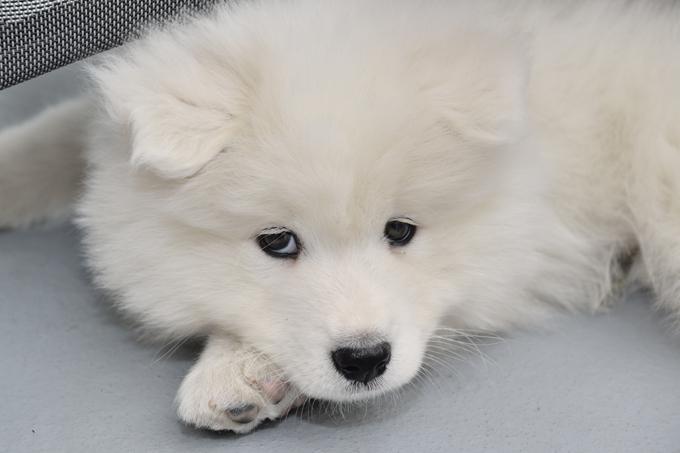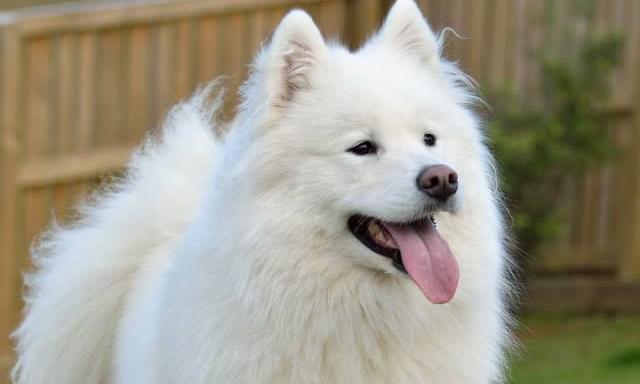The first image is the image on the left, the second image is the image on the right. For the images displayed, is the sentence "There are two dogs in total." factually correct? Answer yes or no. Yes. The first image is the image on the left, the second image is the image on the right. Examine the images to the left and right. Is the description "An image shows a white dog with something edible in front of him." accurate? Answer yes or no. No. 